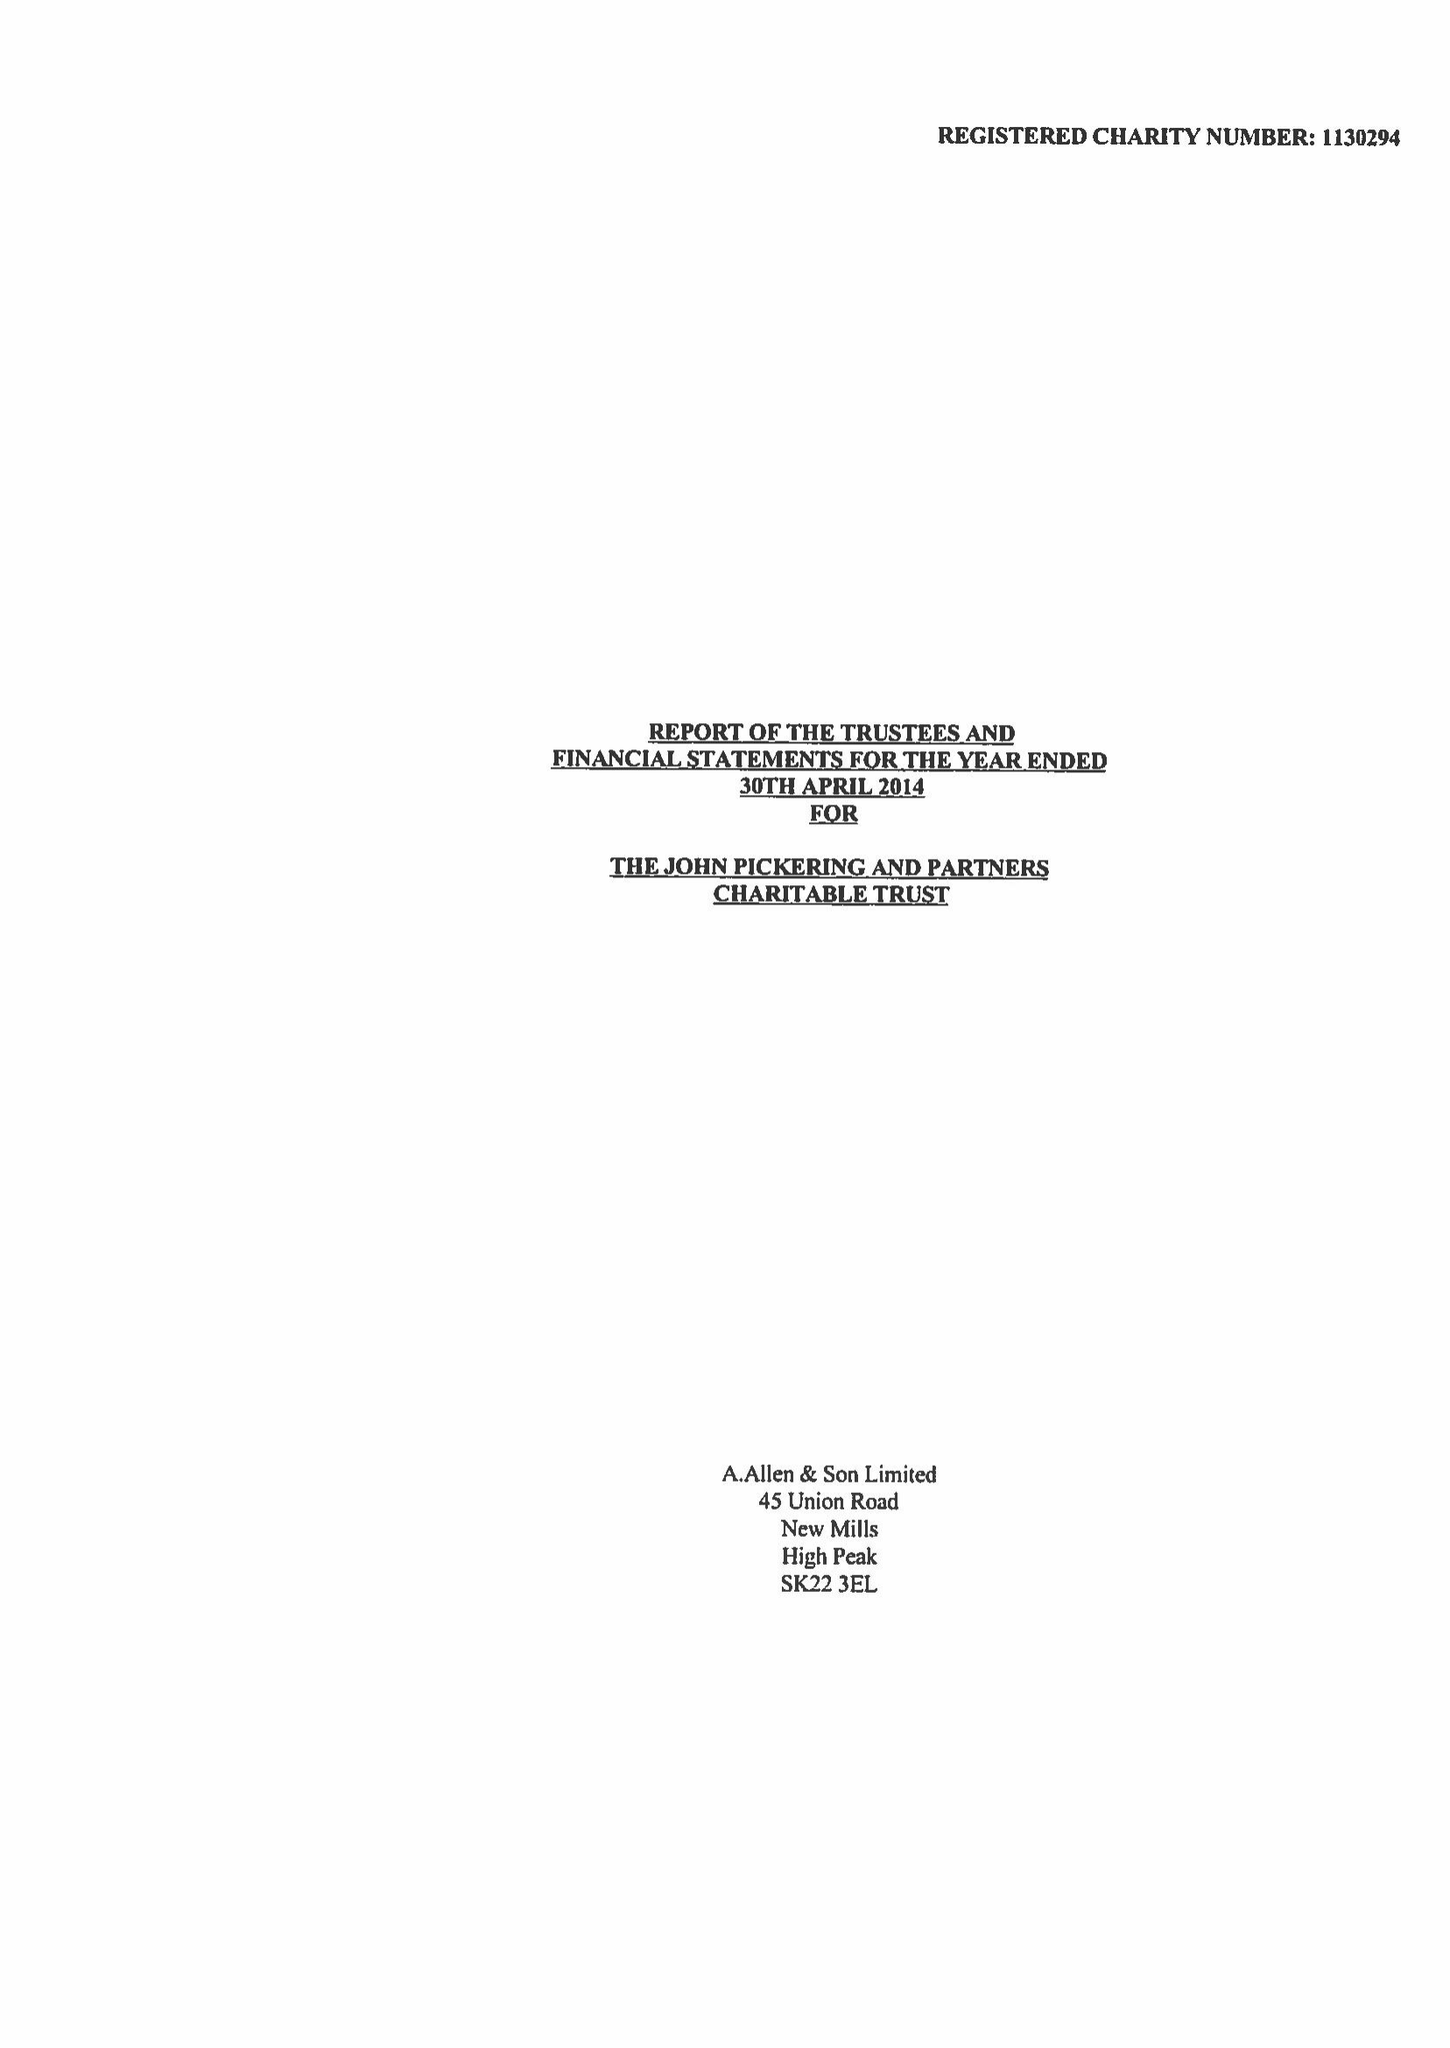What is the value for the address__postcode?
Answer the question using a single word or phrase. SK22 3EL 